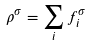Convert formula to latex. <formula><loc_0><loc_0><loc_500><loc_500>\rho ^ { \sigma } = \sum _ { i } f _ { i } ^ { \sigma }</formula> 